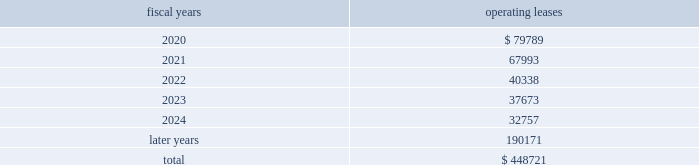Lease commitments the company leases certain land , facilities , equipment and software under various operating leases that expire at various dates through 2057 .
The lease agreements frequently include renewal and escalation clauses and require the company to pay taxes , insurance and maintenance costs .
Total rental expense under operating leases was approximatelya $ 92.3 million in fiscal 2019 , $ 84.9 million in fiscal 2018 and $ 58.8 million in fiscal 2017 .
The following is a schedule of futureff minimum rental payments required under long-term operating leases at november 2 , 2019 : operating fiscal years leases .
10 .
Commitments and contingencies from time to time , in the ordinary course of the company 2019s business , various claims , charges and litigation are asserted or commenced against the company arising from , or related to , among other things , contractual matters , patents , trademarks , personal injury , environmental matters , product liability , insurance coverage , employment or employment benefits .
As to such claims and litigation , the company can give no assurance that it will prevail .
The company does not believe that any current legal matters will have a material adverse effect on the company 2019s financial position , results of operations or cash flows .
11 .
Retirement plans the company and its subsidiaries have various savings and retirement plans covering substantially all employees .
Defined contribution plans the company maintains a defined contribution plan for the benefit of its eligible u.s .
Employees .
This plan provides for company contributions of up to 5% ( 5 % ) of each participant 2019s total eligible compensation .
In addition , the company contributes an amount equal to each participant 2019s pre-tax contribution , if any , up to a maximum of 3% ( 3 % ) of each participant 2019s total eligible compensation .
The total expense related to the defined contribution plans for u.s .
Employees was $ 47.7 million in fiscal 2019 , $ 41.4 million in fiscal 2018 and $ 35.8 million in fiscal 2017 .
Non-qualified deferred compensation plan the deferred compensation plan ( dcp ) allows certain members of management and other highly-compensated employees and non-employee directors to defer receipt of all or any portion of their compensation .
The dcp was established to provide participants with the opportunity to defer receiving all or a portion of their compensation , which includes salary , bonus , commissions and director fees .
Under the dcp , the company provides all participants ( other than non-employee directors ) with company contributions equal to 8% ( 8 % ) of eligible deferred contributions .
The dcp is a non-qualified plan that is maintained in a rabbi trust .
The fair value of the investments held in the rabbi trust are presented separately as deferred compensation plan investments , with the current portion of the investment included in prepaid expenses and other current assets in the consolidated balance sheets .
See note 2j , fair value , for further information on these investments .
The deferred compensation obligation represents dcp participant accumulated deferrals and earnings thereon since the inception of the dcp net of withdrawals .
The deferred compensation obligation is presented separately as deferred compensation plan liability , with the current portion of the obligation in accrued liabilities in the consolidated balance sheets .
The company 2019s liability under the dcp is an unsecured general obligation of the company .
Analog devices , inc .
Notes to consolidated financial statements 2014 ( continued ) .
What is the expected percentage change in total rental expense under operating leases in 2020 compare to 2019? 
Computations: (((79789 / 1000) - 92.3) / 92.3)
Answer: -0.13555. Lease commitments the company leases certain land , facilities , equipment and software under various operating leases that expire at various dates through 2057 .
The lease agreements frequently include renewal and escalation clauses and require the company to pay taxes , insurance and maintenance costs .
Total rental expense under operating leases was approximatelya $ 92.3 million in fiscal 2019 , $ 84.9 million in fiscal 2018 and $ 58.8 million in fiscal 2017 .
The following is a schedule of futureff minimum rental payments required under long-term operating leases at november 2 , 2019 : operating fiscal years leases .
10 .
Commitments and contingencies from time to time , in the ordinary course of the company 2019s business , various claims , charges and litigation are asserted or commenced against the company arising from , or related to , among other things , contractual matters , patents , trademarks , personal injury , environmental matters , product liability , insurance coverage , employment or employment benefits .
As to such claims and litigation , the company can give no assurance that it will prevail .
The company does not believe that any current legal matters will have a material adverse effect on the company 2019s financial position , results of operations or cash flows .
11 .
Retirement plans the company and its subsidiaries have various savings and retirement plans covering substantially all employees .
Defined contribution plans the company maintains a defined contribution plan for the benefit of its eligible u.s .
Employees .
This plan provides for company contributions of up to 5% ( 5 % ) of each participant 2019s total eligible compensation .
In addition , the company contributes an amount equal to each participant 2019s pre-tax contribution , if any , up to a maximum of 3% ( 3 % ) of each participant 2019s total eligible compensation .
The total expense related to the defined contribution plans for u.s .
Employees was $ 47.7 million in fiscal 2019 , $ 41.4 million in fiscal 2018 and $ 35.8 million in fiscal 2017 .
Non-qualified deferred compensation plan the deferred compensation plan ( dcp ) allows certain members of management and other highly-compensated employees and non-employee directors to defer receipt of all or any portion of their compensation .
The dcp was established to provide participants with the opportunity to defer receiving all or a portion of their compensation , which includes salary , bonus , commissions and director fees .
Under the dcp , the company provides all participants ( other than non-employee directors ) with company contributions equal to 8% ( 8 % ) of eligible deferred contributions .
The dcp is a non-qualified plan that is maintained in a rabbi trust .
The fair value of the investments held in the rabbi trust are presented separately as deferred compensation plan investments , with the current portion of the investment included in prepaid expenses and other current assets in the consolidated balance sheets .
See note 2j , fair value , for further information on these investments .
The deferred compensation obligation represents dcp participant accumulated deferrals and earnings thereon since the inception of the dcp net of withdrawals .
The deferred compensation obligation is presented separately as deferred compensation plan liability , with the current portion of the obligation in accrued liabilities in the consolidated balance sheets .
The company 2019s liability under the dcp is an unsecured general obligation of the company .
Analog devices , inc .
Notes to consolidated financial statements 2014 ( continued ) .
What is the percentage change in total rental expense under operating leases in 2019 compare to 2018? 
Computations: ((92.3 - 84.9) / 84.9)
Answer: 0.08716. Lease commitments the company leases certain land , facilities , equipment and software under various operating leases that expire at various dates through 2057 .
The lease agreements frequently include renewal and escalation clauses and require the company to pay taxes , insurance and maintenance costs .
Total rental expense under operating leases was approximatelya $ 92.3 million in fiscal 2019 , $ 84.9 million in fiscal 2018 and $ 58.8 million in fiscal 2017 .
The following is a schedule of futureff minimum rental payments required under long-term operating leases at november 2 , 2019 : operating fiscal years leases .
10 .
Commitments and contingencies from time to time , in the ordinary course of the company 2019s business , various claims , charges and litigation are asserted or commenced against the company arising from , or related to , among other things , contractual matters , patents , trademarks , personal injury , environmental matters , product liability , insurance coverage , employment or employment benefits .
As to such claims and litigation , the company can give no assurance that it will prevail .
The company does not believe that any current legal matters will have a material adverse effect on the company 2019s financial position , results of operations or cash flows .
11 .
Retirement plans the company and its subsidiaries have various savings and retirement plans covering substantially all employees .
Defined contribution plans the company maintains a defined contribution plan for the benefit of its eligible u.s .
Employees .
This plan provides for company contributions of up to 5% ( 5 % ) of each participant 2019s total eligible compensation .
In addition , the company contributes an amount equal to each participant 2019s pre-tax contribution , if any , up to a maximum of 3% ( 3 % ) of each participant 2019s total eligible compensation .
The total expense related to the defined contribution plans for u.s .
Employees was $ 47.7 million in fiscal 2019 , $ 41.4 million in fiscal 2018 and $ 35.8 million in fiscal 2017 .
Non-qualified deferred compensation plan the deferred compensation plan ( dcp ) allows certain members of management and other highly-compensated employees and non-employee directors to defer receipt of all or any portion of their compensation .
The dcp was established to provide participants with the opportunity to defer receiving all or a portion of their compensation , which includes salary , bonus , commissions and director fees .
Under the dcp , the company provides all participants ( other than non-employee directors ) with company contributions equal to 8% ( 8 % ) of eligible deferred contributions .
The dcp is a non-qualified plan that is maintained in a rabbi trust .
The fair value of the investments held in the rabbi trust are presented separately as deferred compensation plan investments , with the current portion of the investment included in prepaid expenses and other current assets in the consolidated balance sheets .
See note 2j , fair value , for further information on these investments .
The deferred compensation obligation represents dcp participant accumulated deferrals and earnings thereon since the inception of the dcp net of withdrawals .
The deferred compensation obligation is presented separately as deferred compensation plan liability , with the current portion of the obligation in accrued liabilities in the consolidated balance sheets .
The company 2019s liability under the dcp is an unsecured general obligation of the company .
Analog devices , inc .
Notes to consolidated financial statements 2014 ( continued ) .
What percentage has renting lease expenses increased from 2017 to 2019? 
Rationale: to find the answer one must look at line 4 where it states the lease expenses for the years of 20172018 , and 2019 . then one must take the 2019 and 2017 lease expenses and subtract them from each other . then divide the answer by the 2017 lease expenses .
Computations: ((92.3 - 58.8) / 58.8)
Answer: 0.56973. 